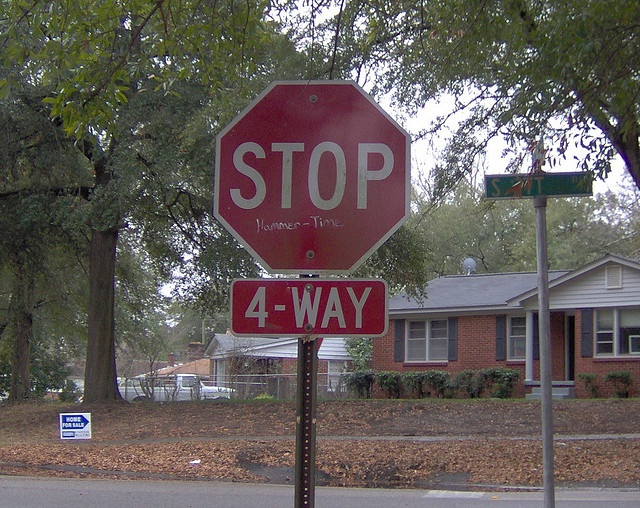Describe the objects in this image and their specific colors. I can see stop sign in darkgreen, maroon, gray, and purple tones and truck in darkgreen, gray, darkgray, and lightgray tones in this image. 